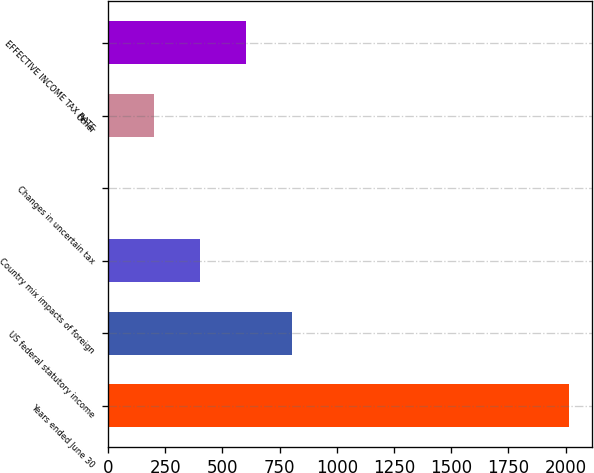Convert chart to OTSL. <chart><loc_0><loc_0><loc_500><loc_500><bar_chart><fcel>Years ended June 30<fcel>US federal statutory income<fcel>Country mix impacts of foreign<fcel>Changes in uncertain tax<fcel>Other<fcel>EFFECTIVE INCOME TAX RATE<nl><fcel>2015<fcel>806.54<fcel>403.72<fcel>0.9<fcel>202.31<fcel>605.13<nl></chart> 